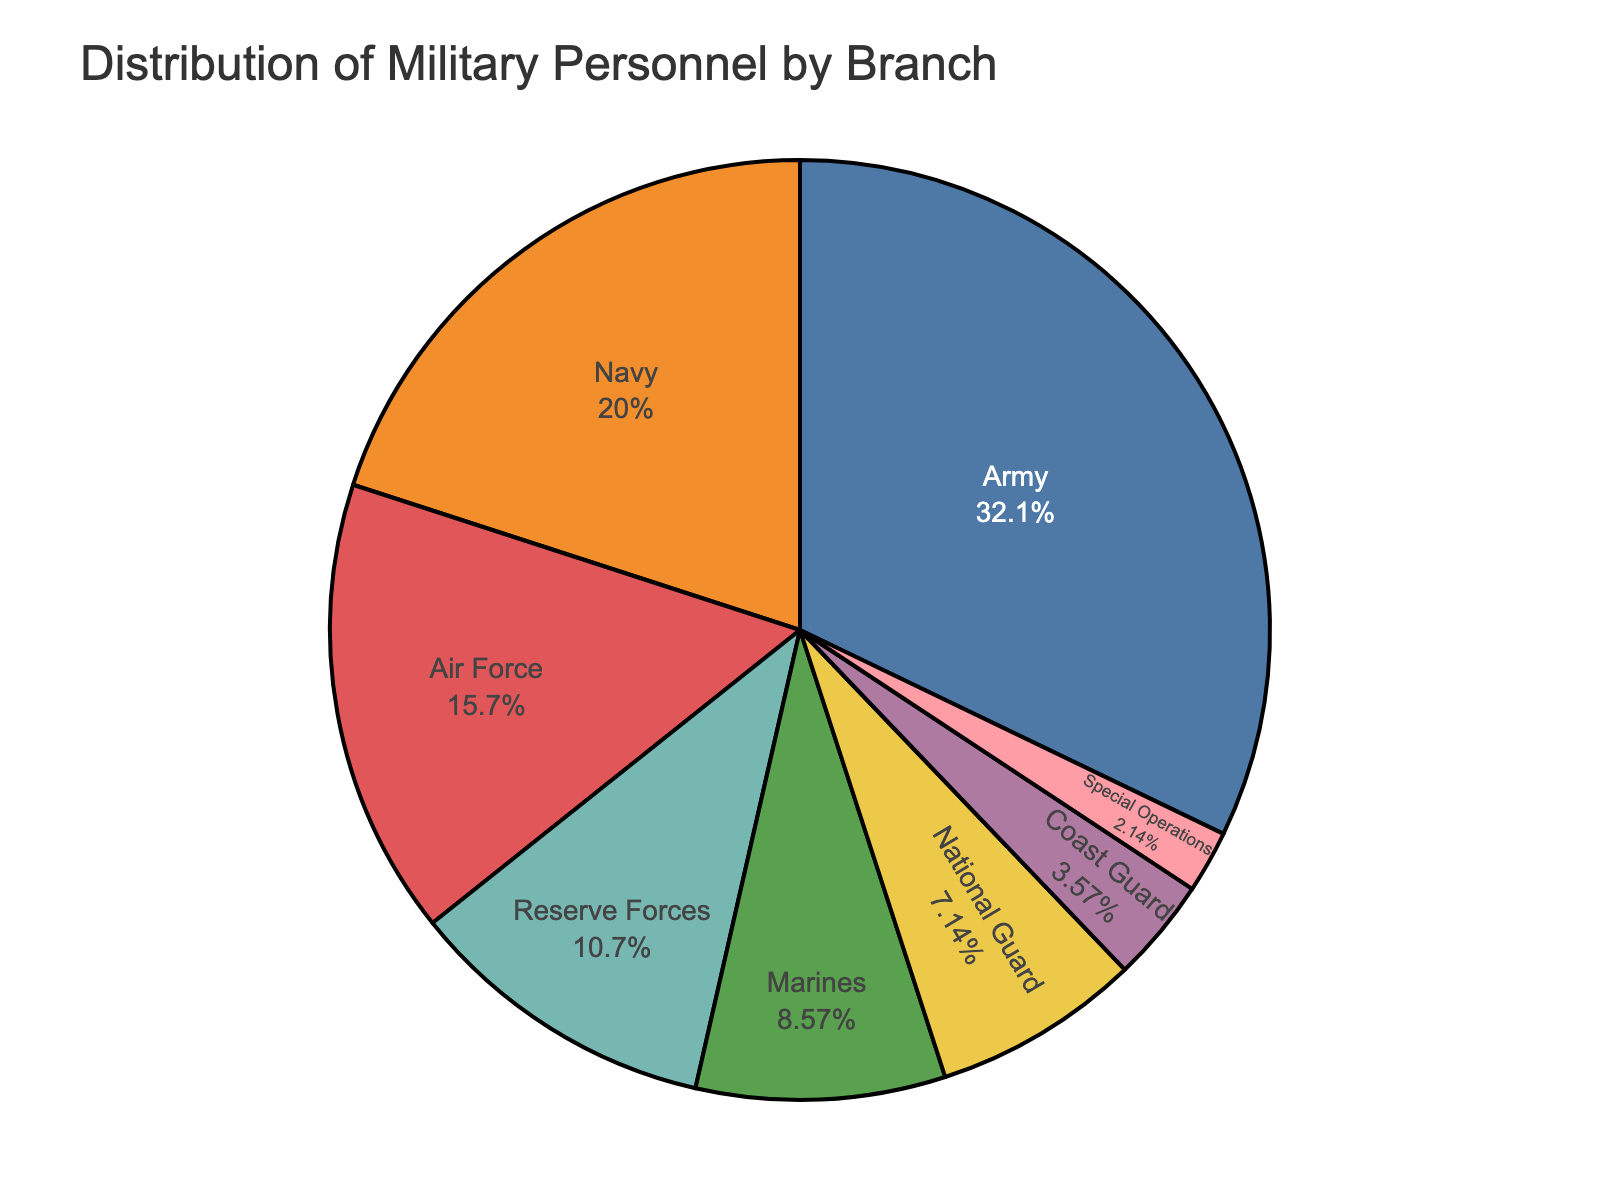Which branch has the largest number of personnel? The figure shows a pie chart with each branch labeled and represented by different portions. The largest portion corresponds to the Army.
Answer: Army How many more personnel are in the Army compared to the Coast Guard? The figure indicates the Army has 45,000 personnel and the Coast Guard has 5,000. Subtracting these gives the difference: 45,000 - 5,000 = 40,000
Answer: 40,000 What percentage of the total military personnel is represented by the Navy? The pie chart displays percentages as well as numbers. The Navy has 28,000 personnel out of the total, which is derived from summing all branches: 45,000 + 28,000 + 22,000 + 12,000 + 5,000 + 3,000 + 15,000 + 10,000 = 140,000. The percentage is (28,000/140,000) * 100 = 20%
Answer: 20% How do the personnel numbers of Marines compare to those of Special Operations? The pie chart indicates that the Marines have 12,000 personnel and Special Operations have 3,000. Thus, the Marines have 12,000 / 3,000 = 4 times more personnel.
Answer: 4 times more Which branches make up more than 15% of the total personnel each? From the pie chart, the percentages are displayed. Those more than 15% are the Army (32.1%) and Navy (20.0%).
Answer: Army and Navy What's the sum of personnel from Reserve Forces, National Guard, and Coast Guard? According to the pie chart, sum the values for Reserve Forces (15,000), National Guard (10,000), and Coast Guard (5,000): 15,000 + 10,000 + 5,000 = 30,000
Answer: 30,000 What is the visual color representation for the Air Force? The legend or labels within the pie chart use specific colors for each branch. The Air Force is represented by a portion colored typically within a certain hue range, but it's explicitly stated to check the slice labeled "Air Force."
Answer: (Specific answer depends on the color legend provided in the pie chart, assumed 'green' for this context.) What fraction of the total personnel does the Marine Corps represent? Sum the total personnel first: 45,000 + 28,000 + 22,000 + 12,000 + 5,000 + 3,000 + 15,000 + 10,000 = 140,000. The Marine Corps has 12,000 personnel. Thus, the fraction is 12,000 / 140,000 = 3/35
Answer: 3/35 